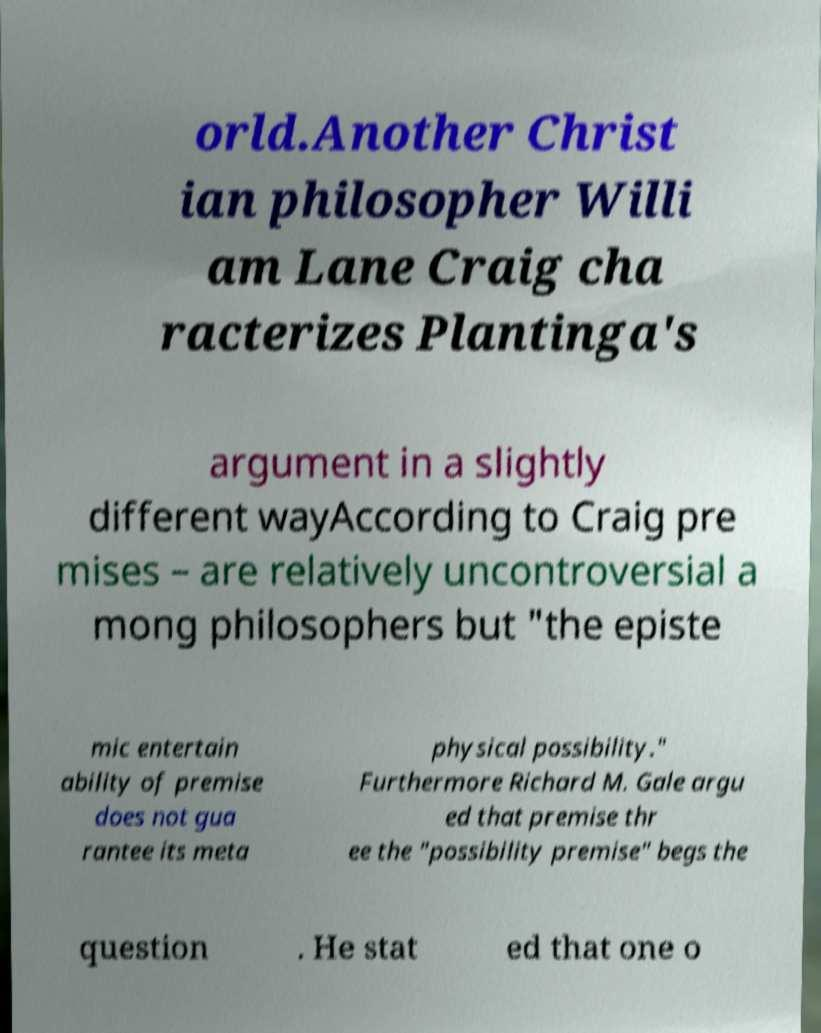For documentation purposes, I need the text within this image transcribed. Could you provide that? orld.Another Christ ian philosopher Willi am Lane Craig cha racterizes Plantinga's argument in a slightly different wayAccording to Craig pre mises – are relatively uncontroversial a mong philosophers but "the episte mic entertain ability of premise does not gua rantee its meta physical possibility." Furthermore Richard M. Gale argu ed that premise thr ee the "possibility premise" begs the question . He stat ed that one o 